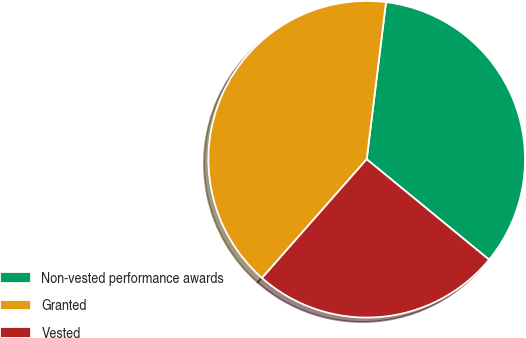Convert chart. <chart><loc_0><loc_0><loc_500><loc_500><pie_chart><fcel>Non-vested performance awards<fcel>Granted<fcel>Vested<nl><fcel>33.99%<fcel>40.45%<fcel>25.56%<nl></chart> 